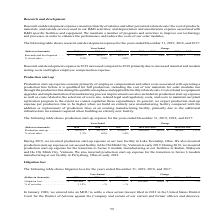According to First Solar's financial document, What are the reasons for higher research and development expense in 2019? Research and development expense in 2019 increased compared to 2018 primarily due to increased material and module testing costs and higher employee compensation expense.. The document states: "Research and development expense in 2019 increased compared to 2018 primarily due to increased material and module testing costs and higher employee c..." Also, What is the percentage of net sales in 2017? According to the financial document, 3.0%. The relevant text states: ",139 14% $ (4,101) (5)% % of net sales . 3.2% 3.8% 3.0%..." Also, What are components of research and development expense? Research and development expense consists primarily of salaries and other personnel-related costs; the cost of products, materials, and outside services used in our R&D activities; and depreciation and amortization expense associated with R&D specific facilities and equipment.. The document states: "Research and development expense consists primarily of salaries and other personnel-related costs; the cost of products, materials, and outside servic..." Also, can you calculate: What is the amount of net sales derived in 2017? Based on the calculation: 88,573 / 3.0% , the result is 2952433.33 (in thousands). This is based on the information: "139 14% $ (4,101) (5)% % of net sales . 3.2% 3.8% 3.0% 17 Research and development . $ 96,611 $ 84,472 $ 88,573 $ 12,139 14% $ (4,101) (5)% % of net sales . 3.2% 3.8% 3.0%..." The key data points involved are: 3.0, 88,573. Also, can you calculate: What is the net difference in research and development expense between 2019 and 2017? Based on the calculation: 96,611 - 88,573 , the result is 8038 (in thousands). This is based on the information: "17 Research and development . $ 96,611 $ 84,472 $ 88,573 $ 12,139 14% $ (4,101) (5)% % of net sales . 3.2% 3.8% 3.0% 2018 2018 over 2017 Research and development . $ 96,611 $ 84,472 $ 88,573 $ 12,139 ..." The key data points involved are: 88,573, 96,611. Also, can you calculate: What is the difference in net sales amount between 2018 and 2017? To answer this question, I need to perform calculations using the financial data. The calculation is: (84,472 / 3.8%) - (88,573 / 3.0%) , which equals -729485.96 (in thousands). This is based on the information: "139 14% $ (4,101) (5)% % of net sales . 3.2% 3.8% 3.0% 17 Research and development . $ 96,611 $ 84,472 $ 88,573 $ 12,139 14% $ (4,101) (5)% % of net sales . 3.2% 3.8% 3.0% 8 over 2017 Research and dev..." The key data points involved are: 3.0, 3.8, 84,472. 